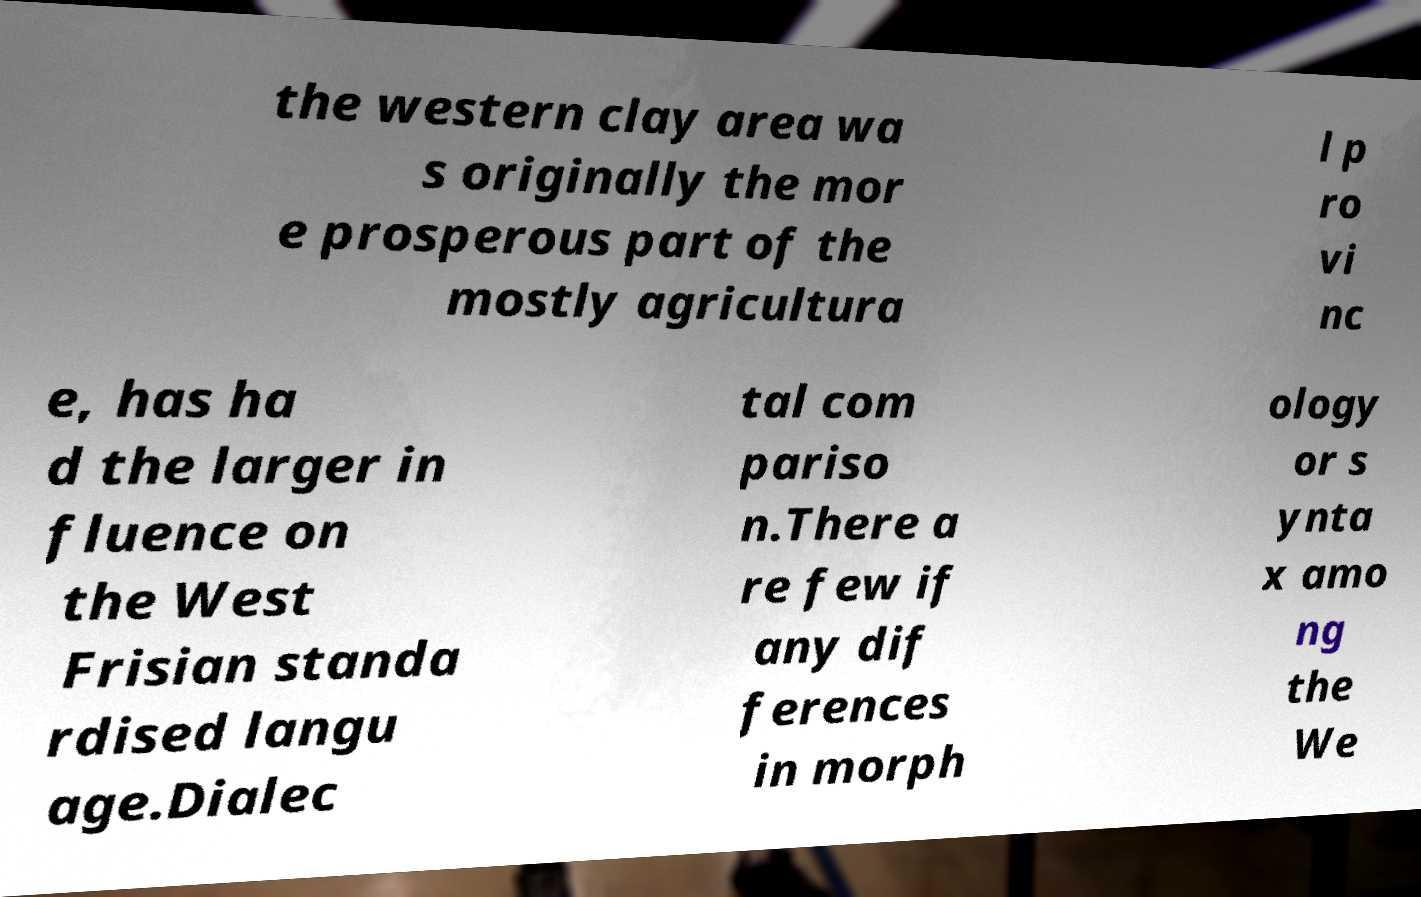For documentation purposes, I need the text within this image transcribed. Could you provide that? the western clay area wa s originally the mor e prosperous part of the mostly agricultura l p ro vi nc e, has ha d the larger in fluence on the West Frisian standa rdised langu age.Dialec tal com pariso n.There a re few if any dif ferences in morph ology or s ynta x amo ng the We 